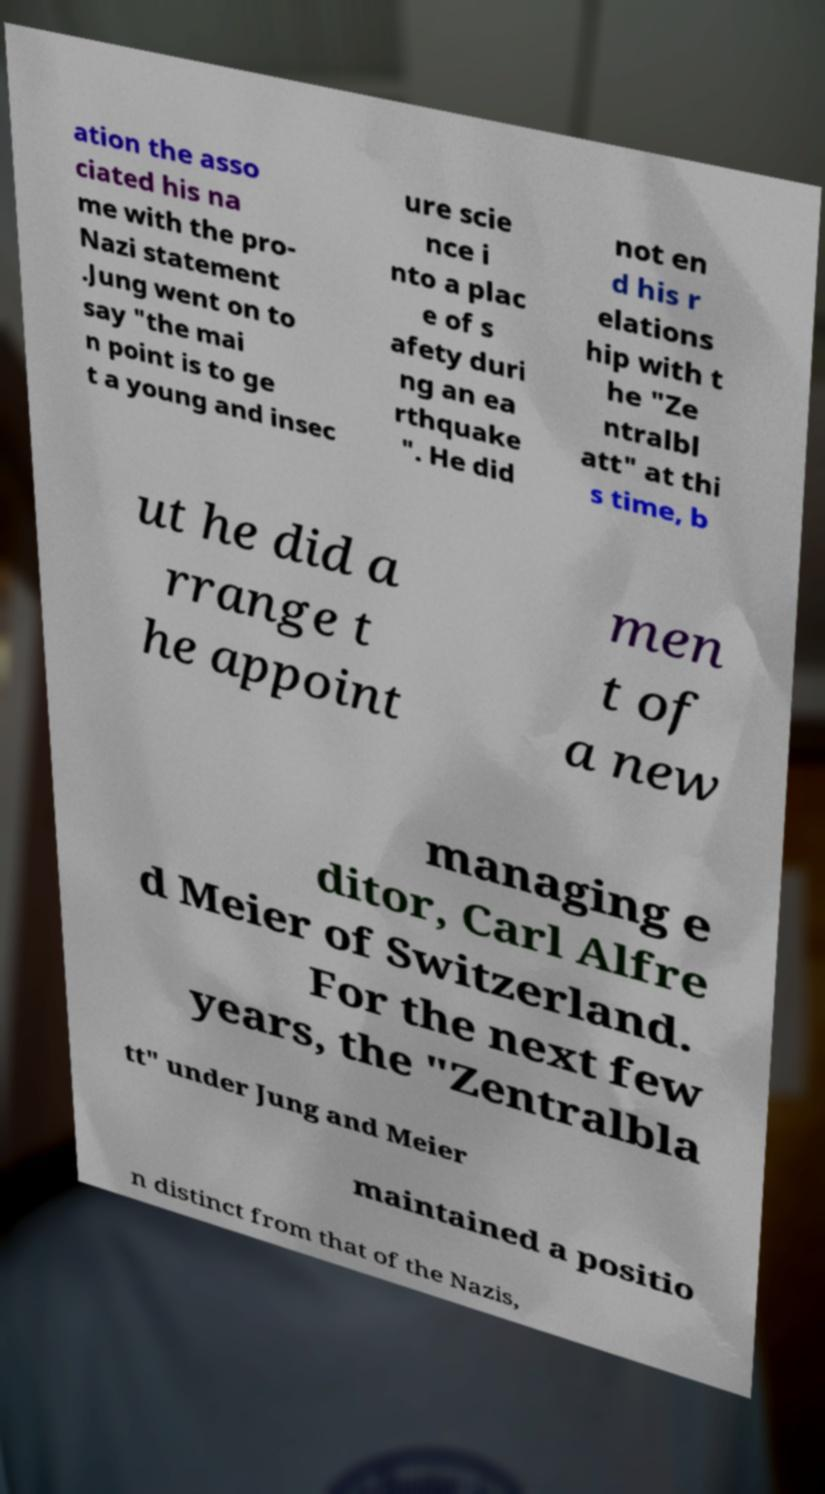I need the written content from this picture converted into text. Can you do that? ation the asso ciated his na me with the pro- Nazi statement .Jung went on to say "the mai n point is to ge t a young and insec ure scie nce i nto a plac e of s afety duri ng an ea rthquake ". He did not en d his r elations hip with t he "Ze ntralbl att" at thi s time, b ut he did a rrange t he appoint men t of a new managing e ditor, Carl Alfre d Meier of Switzerland. For the next few years, the "Zentralbla tt" under Jung and Meier maintained a positio n distinct from that of the Nazis, 